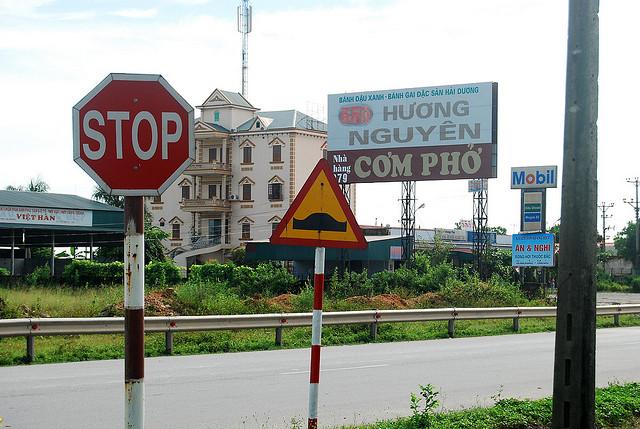What does the triangle shaped sign mean?
Keep it brief. Bump. Is there a Mobil gas station close by?
Quick response, please. Yes. How many signs are near the road?
Write a very short answer. 5. 